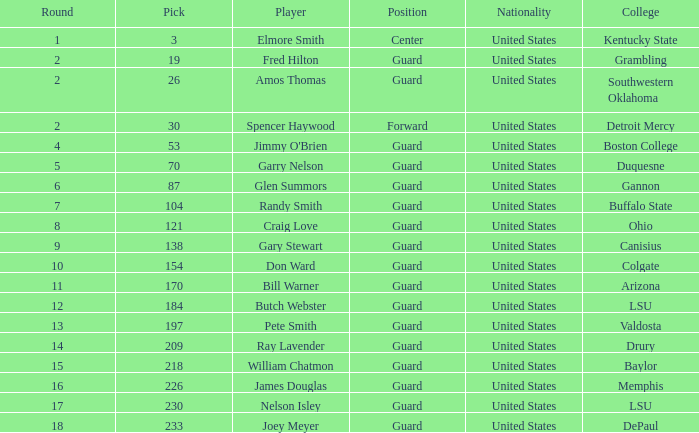What is the total choice for boston college? 1.0. 